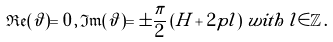<formula> <loc_0><loc_0><loc_500><loc_500>\mathfrak { R e } ( \vartheta ) = 0 \, , \, \mathfrak { I m } ( \vartheta ) = \pm \frac { \pi } { 2 } \left ( H + 2 p l \right ) \, w i t h \, l \in \mathbb { Z } \, .</formula> 